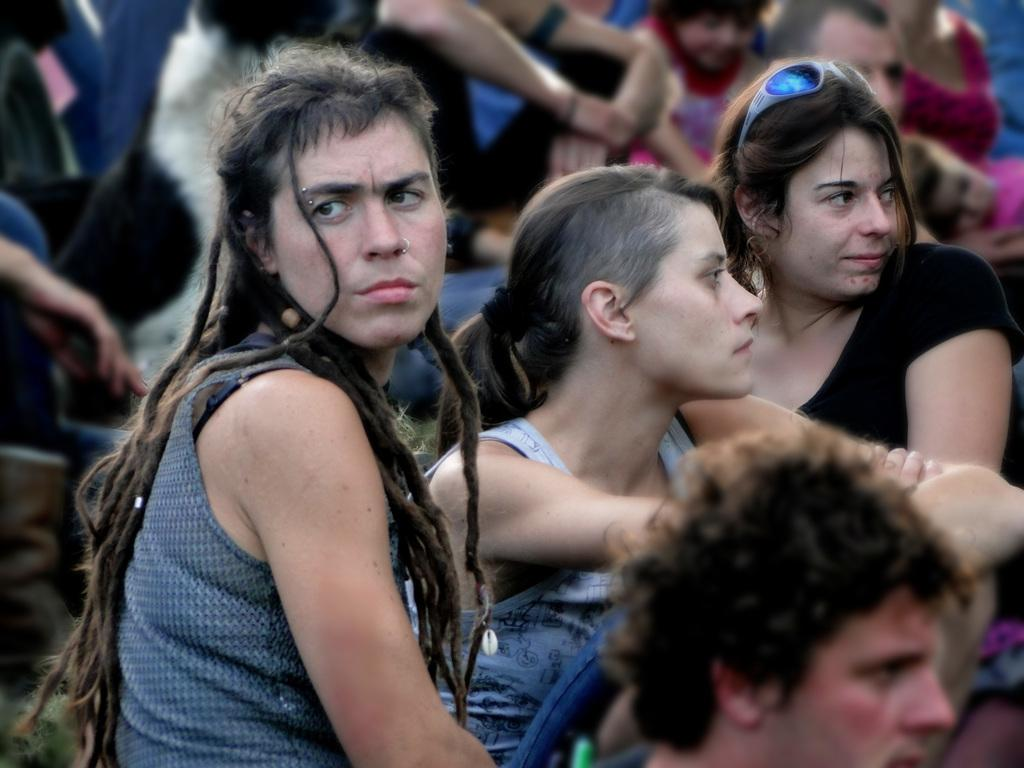How many people are visible in the image? There are few persons in the image. Can you describe the location of the people in the image? There are people in the background of the image. What is the quality of the image? The image is blurry. What type of chain can be seen connecting the people in the image? There is no chain connecting the people in the image, as the facts provided do not mention any chains. 